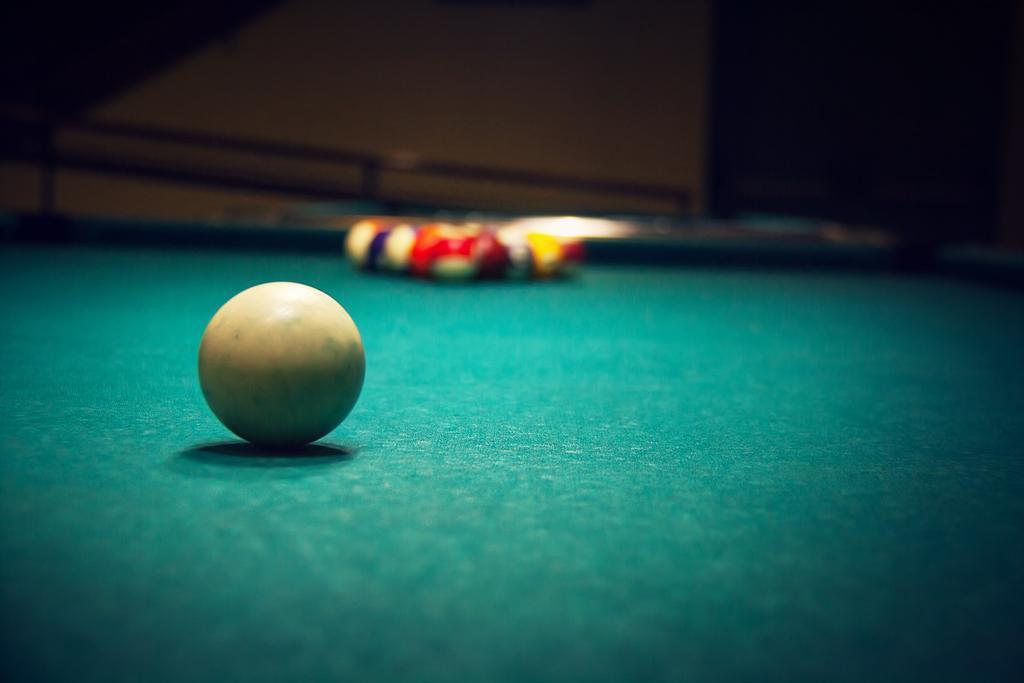Can you describe this image briefly? In the center of the image there is a billiard table. On which there are billiard balls. 